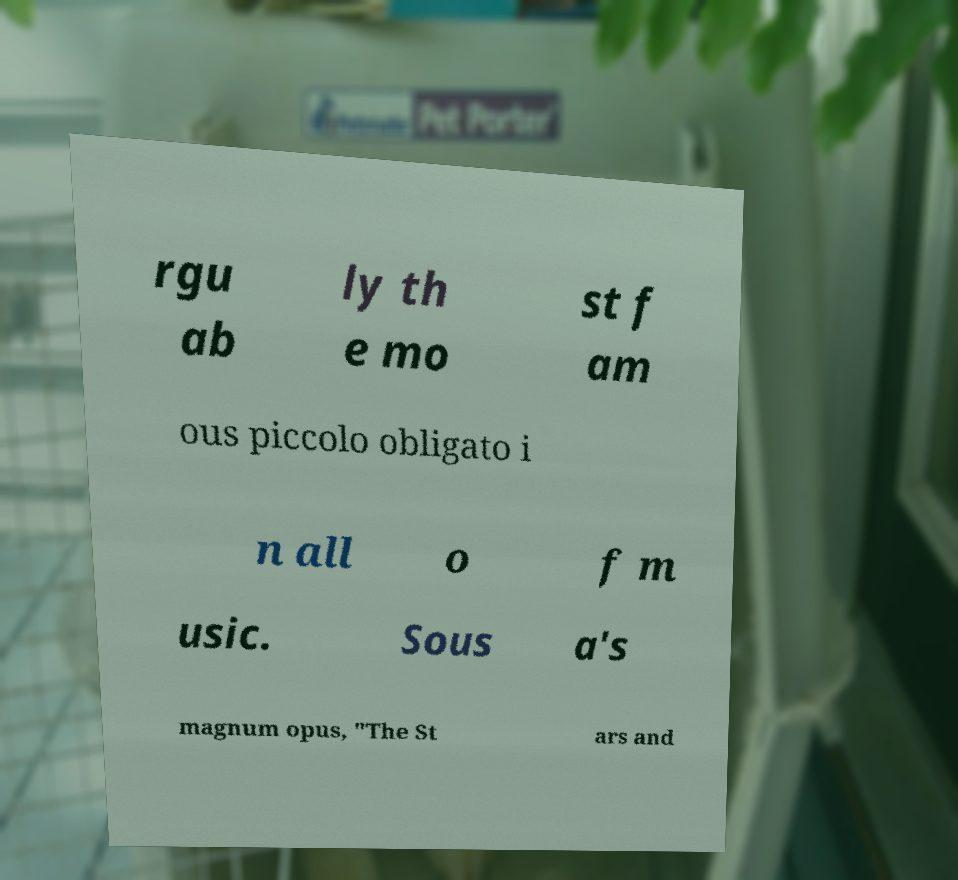Can you accurately transcribe the text from the provided image for me? rgu ab ly th e mo st f am ous piccolo obligato i n all o f m usic. Sous a's magnum opus, "The St ars and 